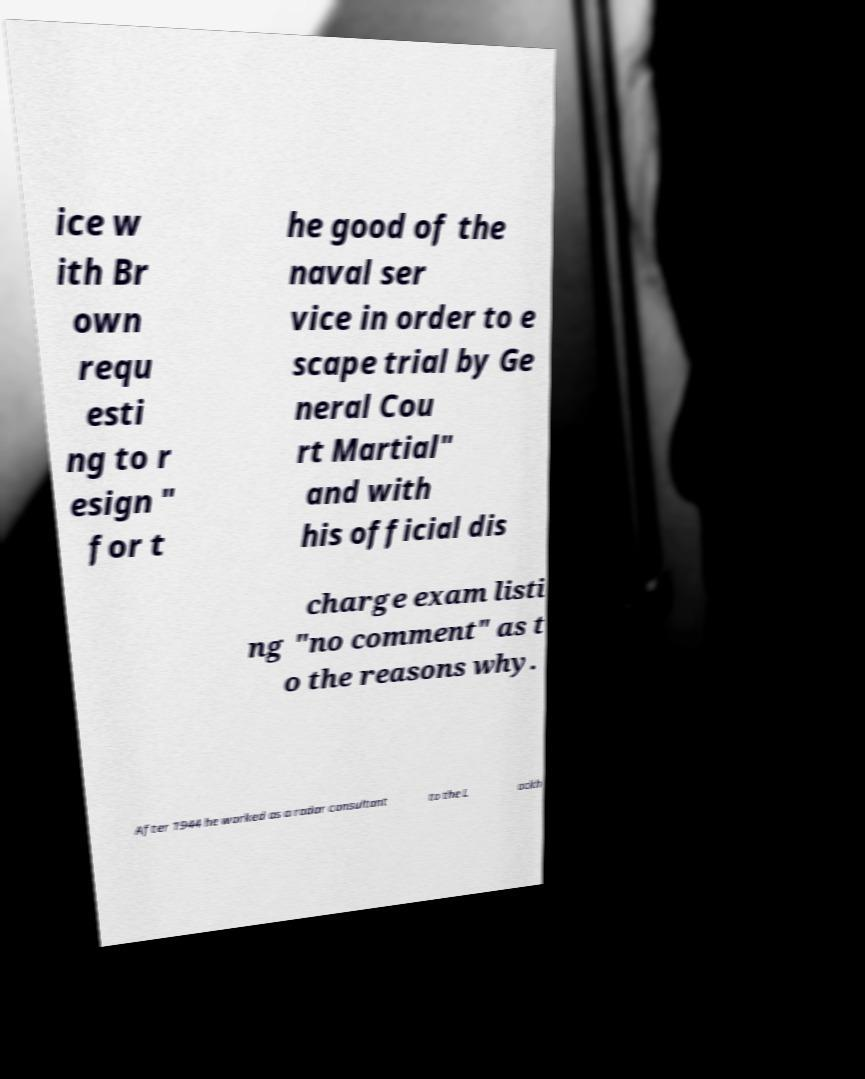For documentation purposes, I need the text within this image transcribed. Could you provide that? ice w ith Br own requ esti ng to r esign " for t he good of the naval ser vice in order to e scape trial by Ge neral Cou rt Martial" and with his official dis charge exam listi ng "no comment" as t o the reasons why. After 1944 he worked as a radar consultant to the L ockh 